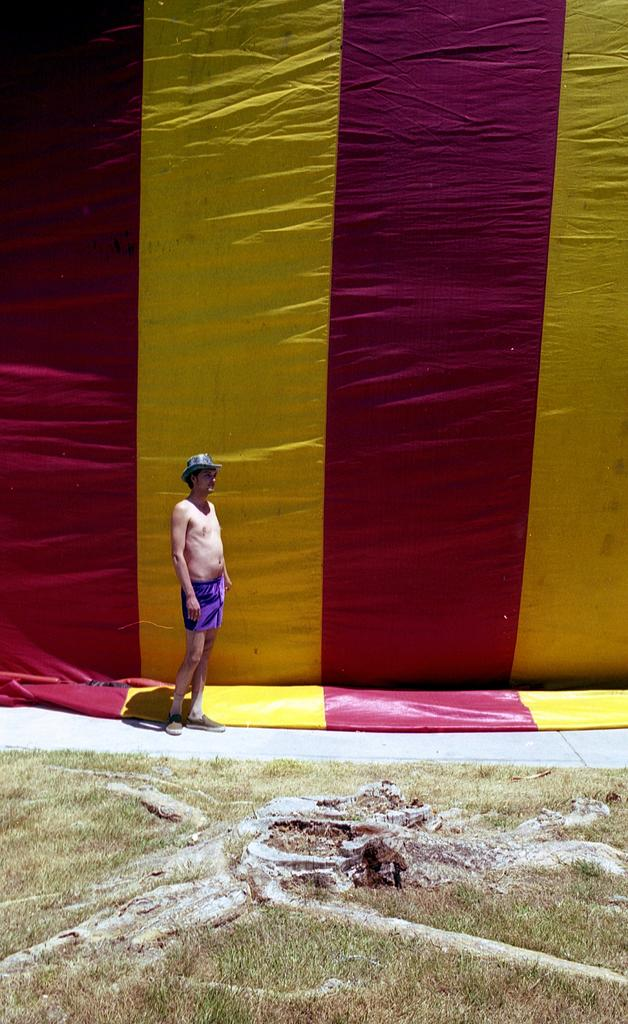What is the main subject of the image? There is a man standing in the image. Where is the man standing? The man is standing on the floor. What is located behind the man? There is a curtain behind the man. What type of natural environment can be seen in the image? Grass is visible in the image. How many sheep are visible in the image? There are no sheep present in the image. What is the relationship between the man and the aunt in the image? There is no mention of an aunt in the image, so we cannot determine any relationship between the man and an aunt. 